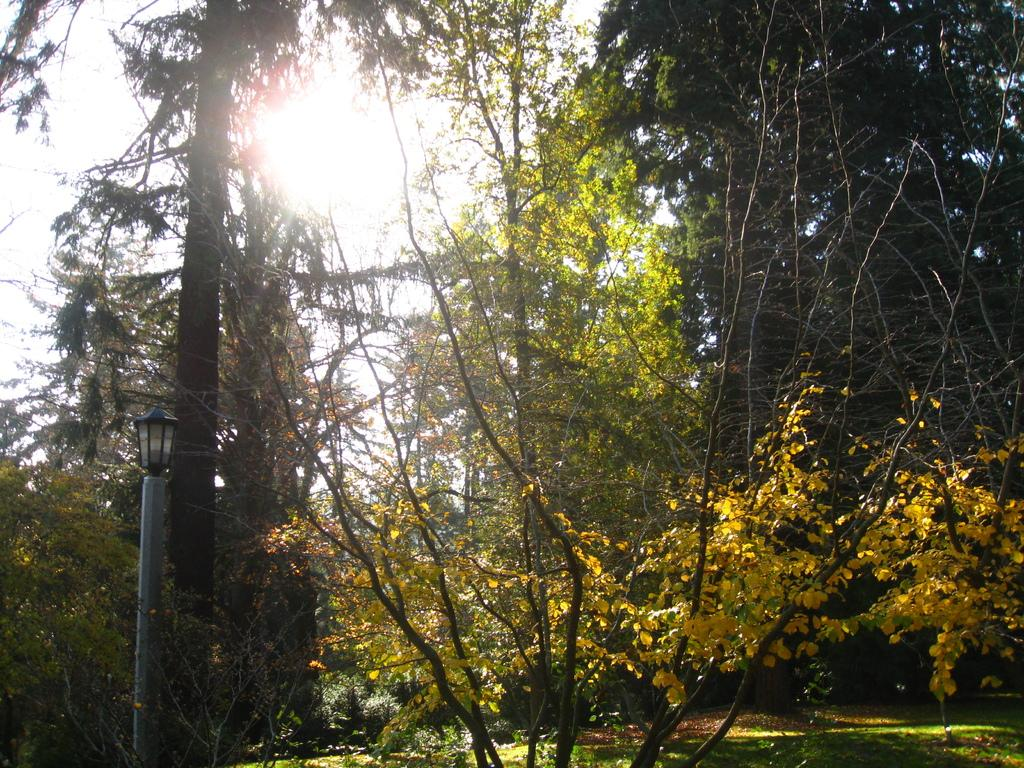What type of vegetation is present in the image? There are trees and plants in the image. What else can be seen in the image besides vegetation? There is a pole in the image. What is attached to the pole? A lamp is attached to the pole. Can you see a kite flying in the image? There is no kite present in the image. What type of watch is the carpenter wearing in the image? There is no carpenter or watch present in the image. 